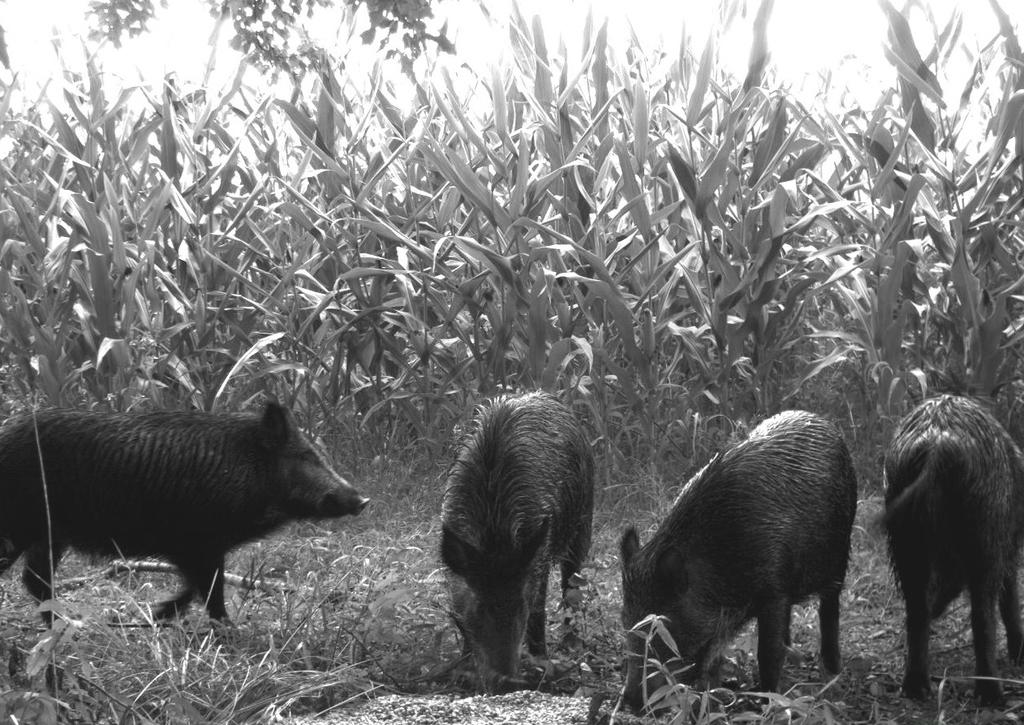What animals are present in the image? There are pigs in the image. What are the pigs doing in the image? The pigs are eating grass in the image. What can be seen in the background of the image? There are plants in the background of the image. What type of home design is depicted in the image? There is no home or design present in the image; it features pigs eating grass with plants in the background. 